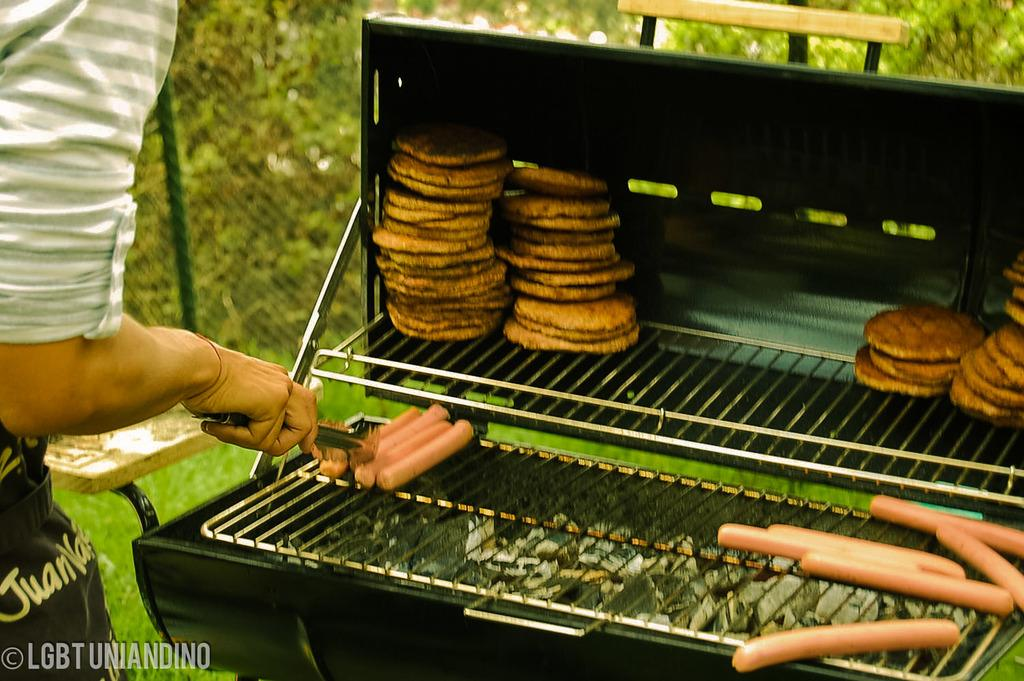<image>
Give a short and clear explanation of the subsequent image. A LGBT Uniandino poster shows a man grilling burgers and hot-dogs. 